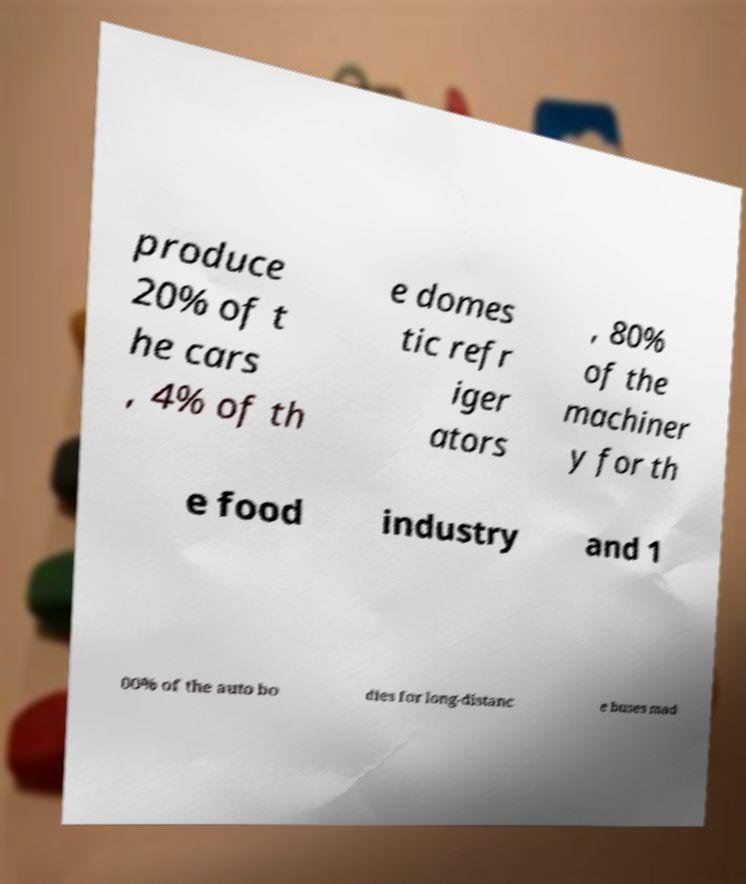What messages or text are displayed in this image? I need them in a readable, typed format. produce 20% of t he cars , 4% of th e domes tic refr iger ators , 80% of the machiner y for th e food industry and 1 00% of the auto bo dies for long-distanc e buses mad 